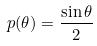<formula> <loc_0><loc_0><loc_500><loc_500>p ( \theta ) = \frac { \sin \theta } { 2 }</formula> 